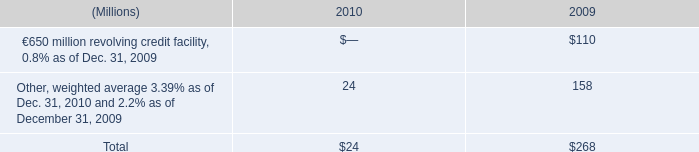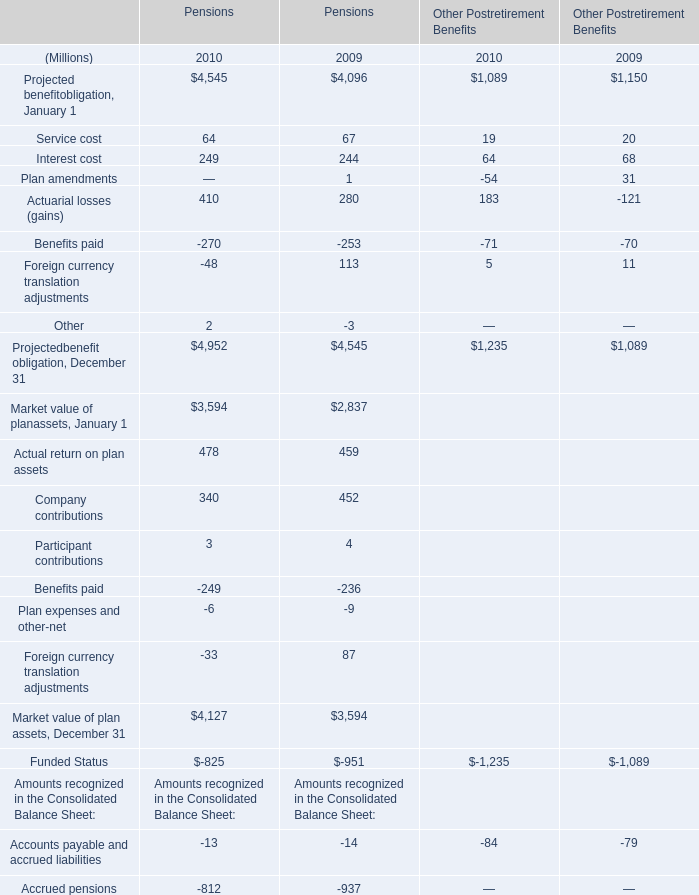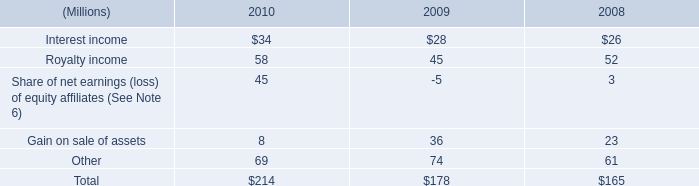what was the change in millions of interest payments from 2009 to 2010? 
Computations: (189 - 201)
Answer: -12.0. 